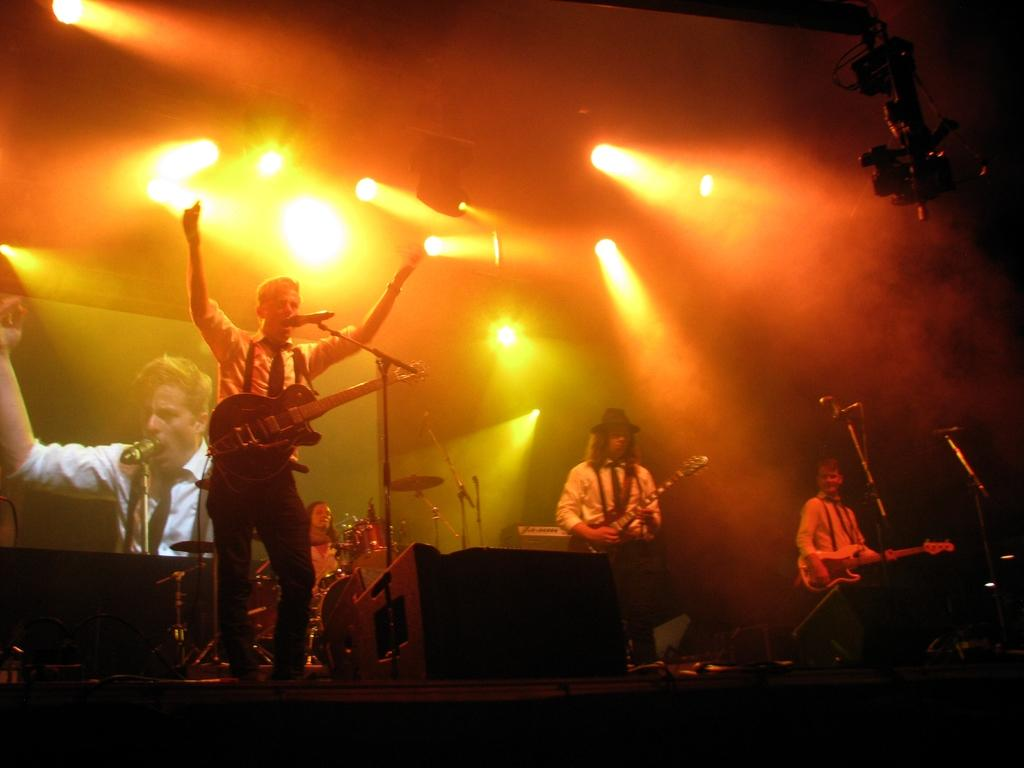What is the man in the image holding? The man in the image is holding a guitar. Are there any other musicians in the image? Yes, there are other musicians in the image. Where are the musicians located in the image? The musicians are in the back side of the image. What can be seen on the ceiling in the image? There are many lights on the ceiling in the image. What type of cushion is being used by the musicians in the image? There is no mention of cushions in the image; the musicians are not using any cushions. 